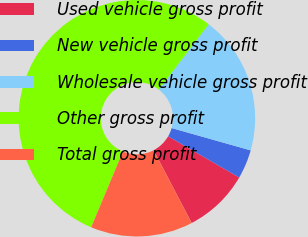<chart> <loc_0><loc_0><loc_500><loc_500><pie_chart><fcel>Used vehicle gross profit<fcel>New vehicle gross profit<fcel>Wholesale vehicle gross profit<fcel>Other gross profit<fcel>Total gross profit<nl><fcel>8.98%<fcel>3.97%<fcel>19.0%<fcel>54.07%<fcel>13.99%<nl></chart> 